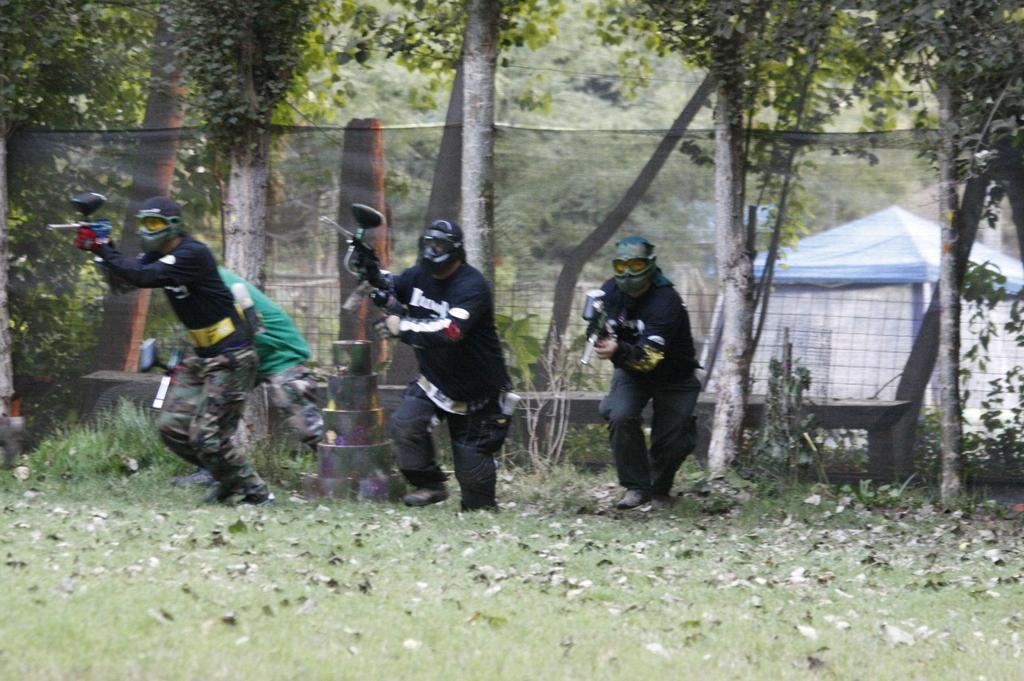Can you describe this image briefly? In the image there are three men with mask running on the grassland, behind them there is fence with trees behind it. 